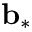Convert formula to latex. <formula><loc_0><loc_0><loc_500><loc_500>{ b } _ { \ast }</formula> 